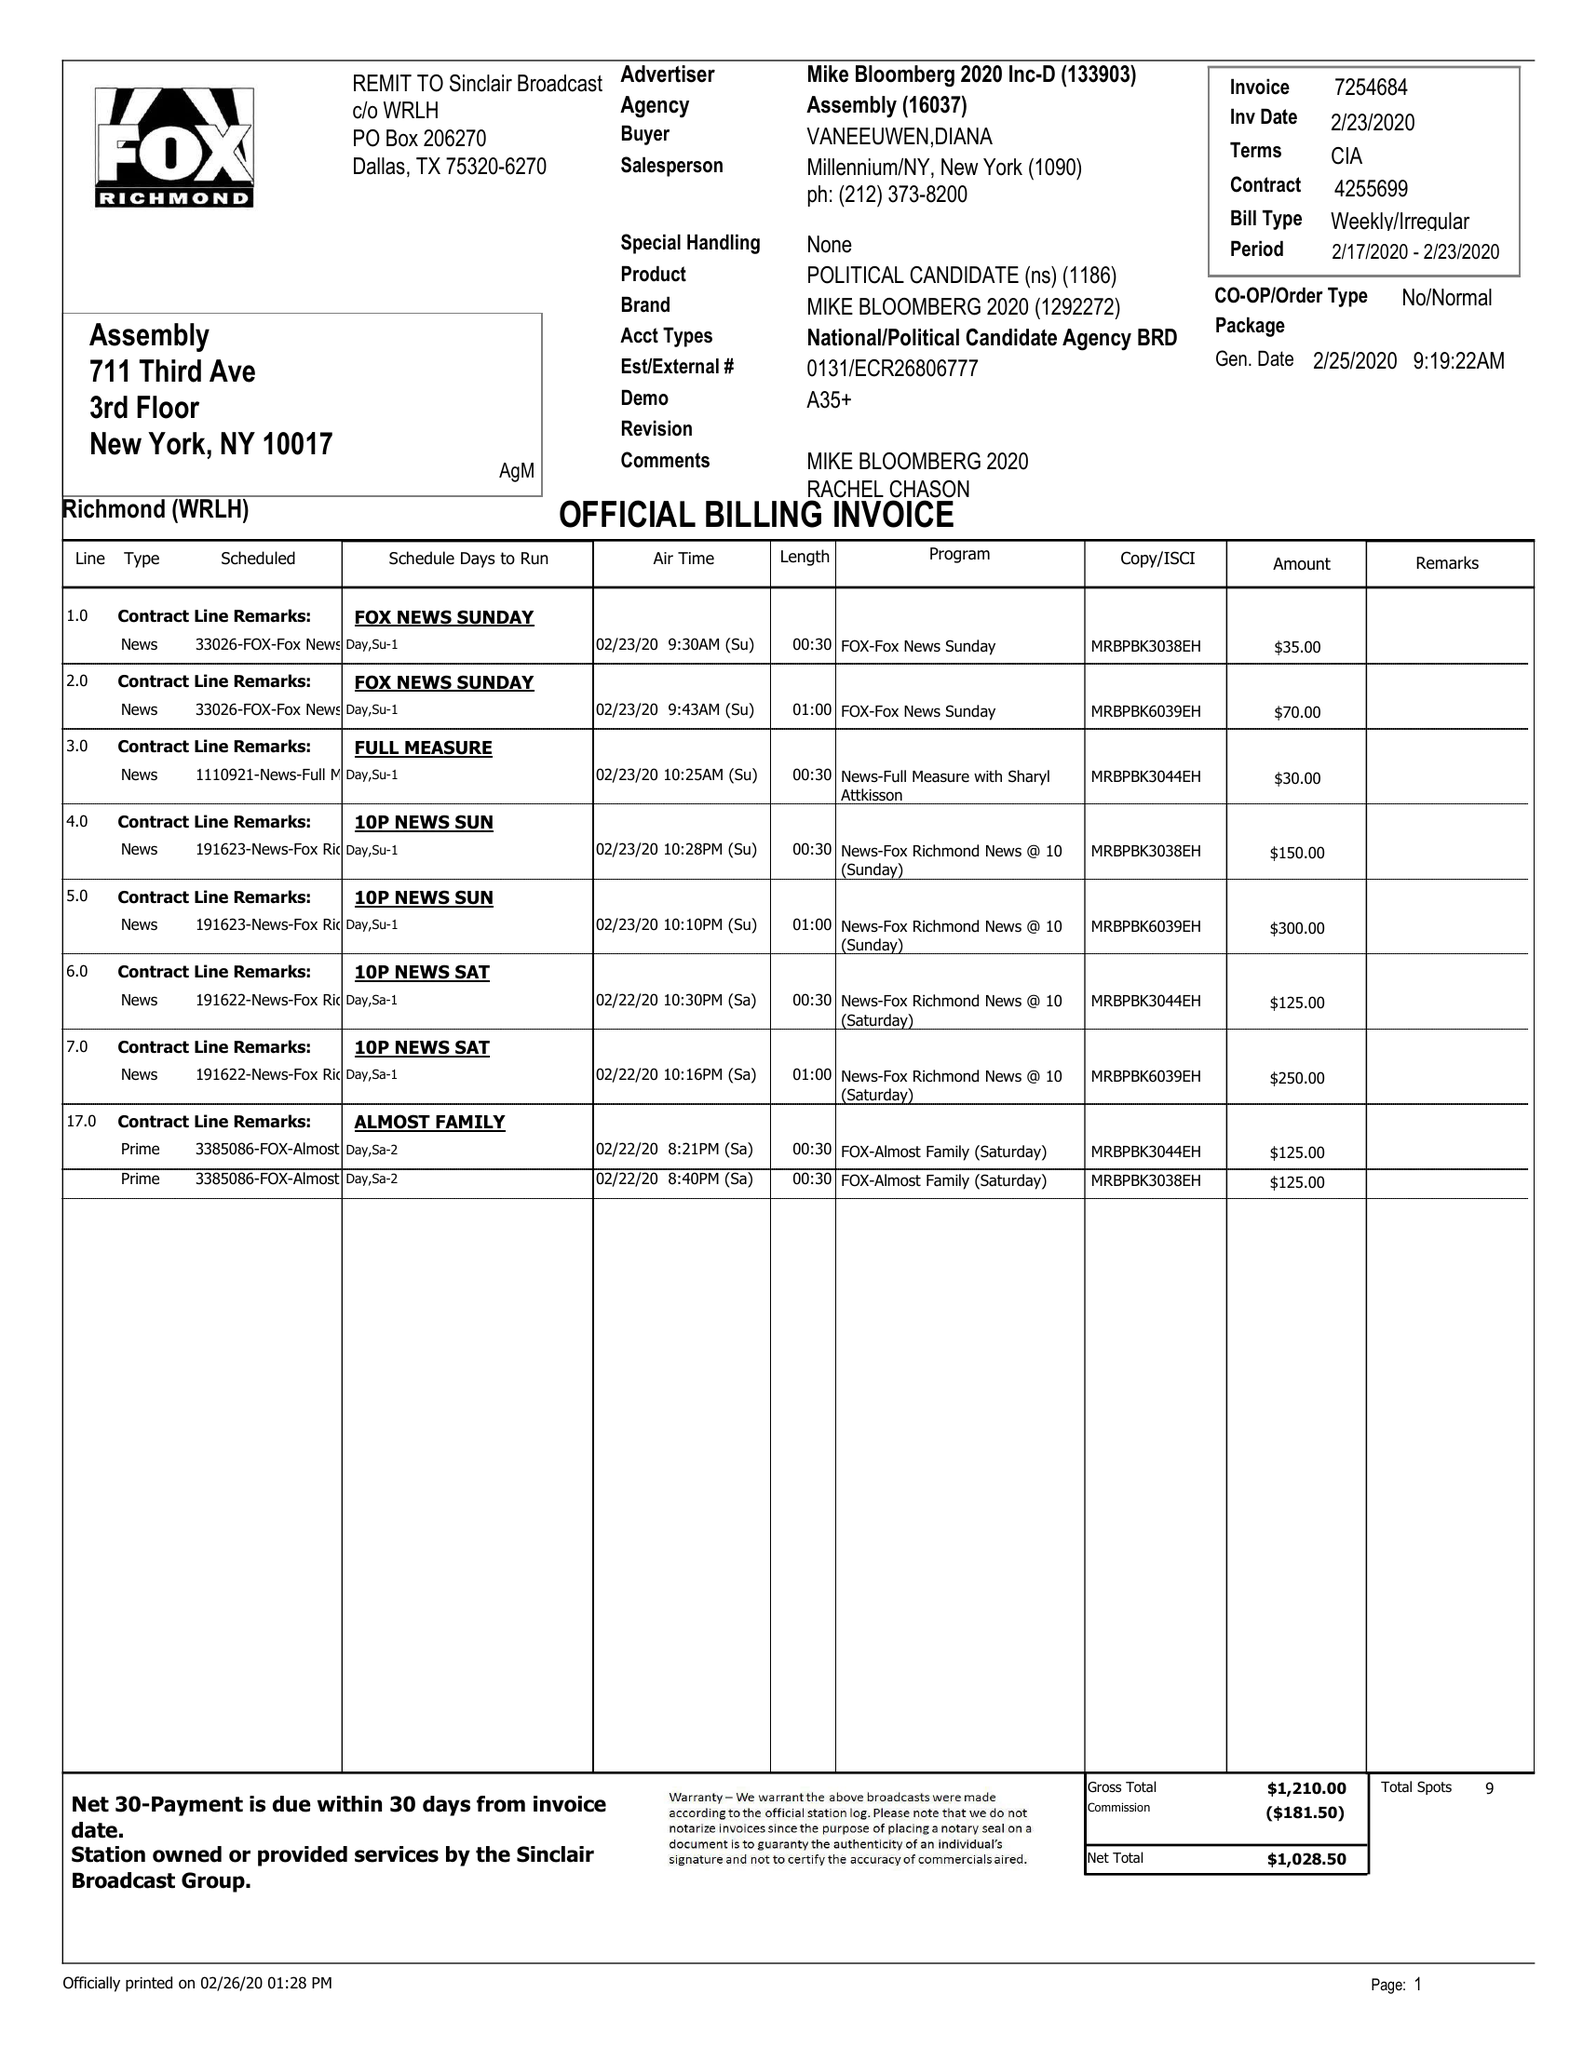What is the value for the advertiser?
Answer the question using a single word or phrase. MIKE BLOOMBERG 2020 INC-D 